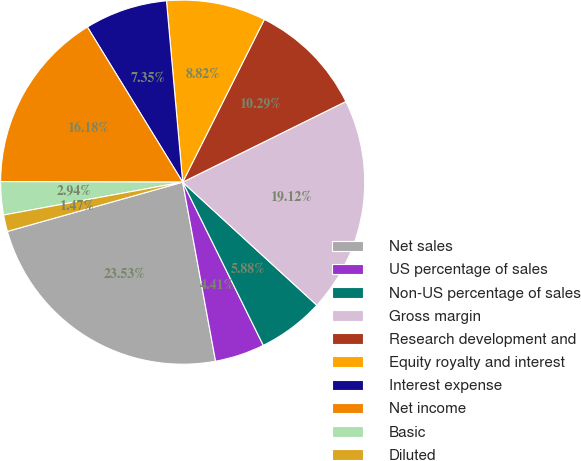Convert chart to OTSL. <chart><loc_0><loc_0><loc_500><loc_500><pie_chart><fcel>Net sales<fcel>US percentage of sales<fcel>Non-US percentage of sales<fcel>Gross margin<fcel>Research development and<fcel>Equity royalty and interest<fcel>Interest expense<fcel>Net income<fcel>Basic<fcel>Diluted<nl><fcel>23.53%<fcel>4.41%<fcel>5.88%<fcel>19.12%<fcel>10.29%<fcel>8.82%<fcel>7.35%<fcel>16.18%<fcel>2.94%<fcel>1.47%<nl></chart> 